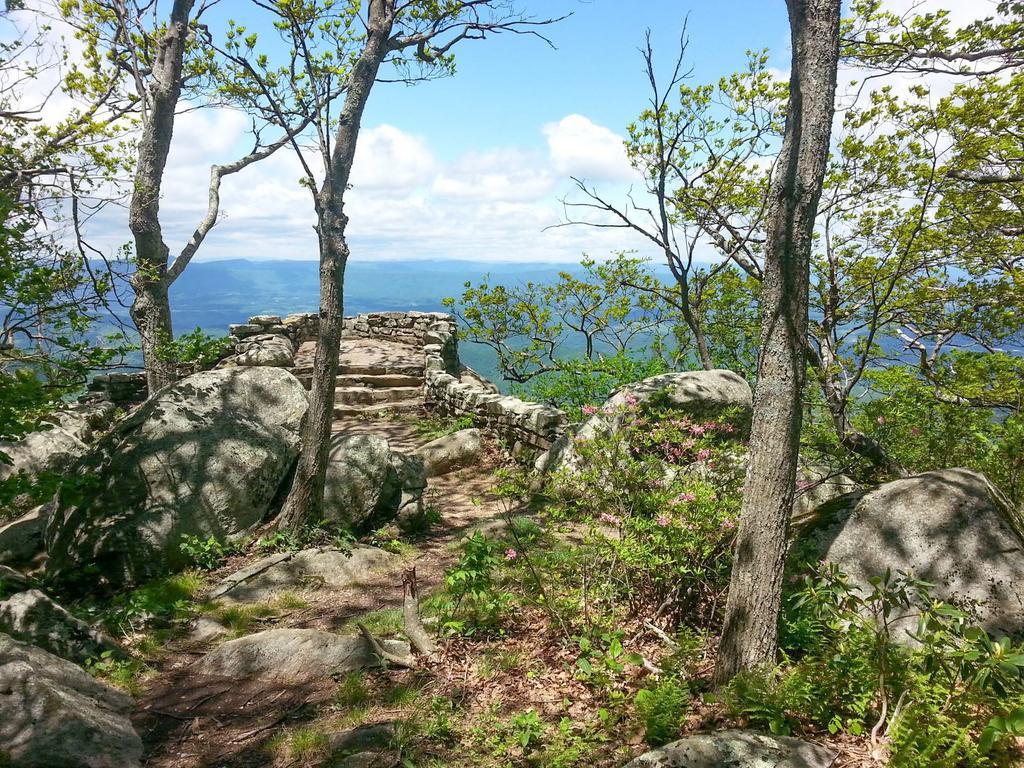Please provide a concise description of this image. In this picture I can number of trees, few rocks and the steps in front. In the background I see the water and the sky. 